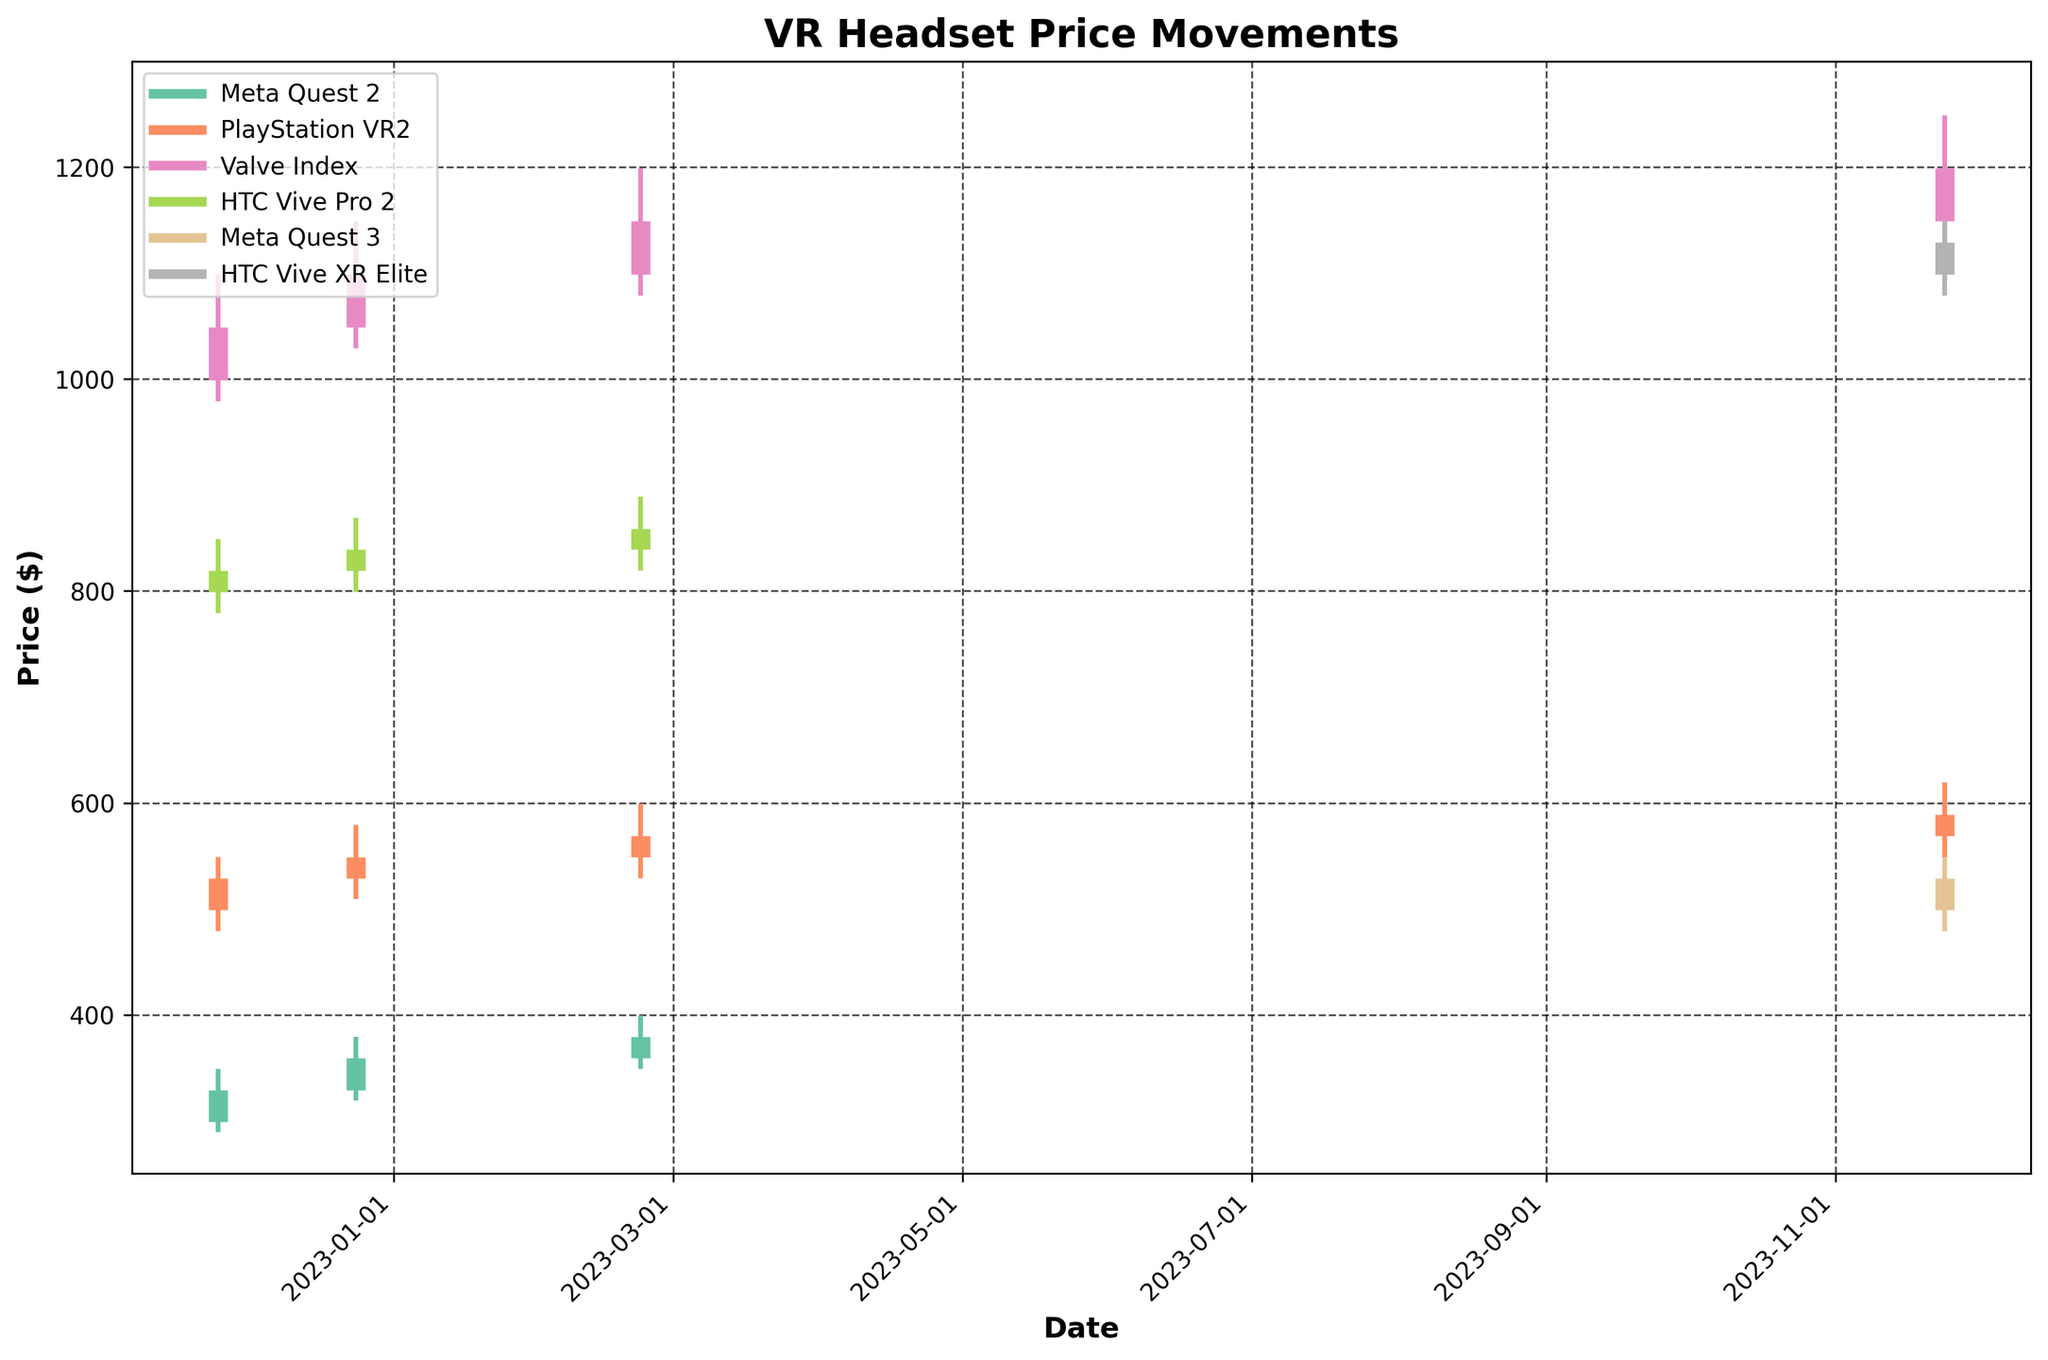How many brands are included in the figure? To determine the number of brands, look for unique labels in the legend.
Answer: 4 What is the highest recorded price for "Meta Quest 3"? For "Meta Quest 3", check the maximum point in the high price line, which shows $549 on 2023-11-24.
Answer: 549 Which VR headset had the highest pre-order price on 2022-11-25? Compare the open prices from 2022-11-25 for all VR headsets and see that "Valve Index" has the highest at $999.
Answer: Valve Index Between which dates did the price of "HTC Vive Pro 2" hit its lowest point? Check the lowest data points for "HTC Vive Pro 2". It hit $779 on 2022-11-25 which is the lowest among all the mentioned dates.
Answer: 2022-11-25 How did the closing price of "PlayStation VR2" change from 2022-12-24 to 2023-02-22? Check the closing prices on both dates (2022-12-24: $549 and 2023-02-22: $569). Subtract the smaller from the larger to determine the change.
Answer: 20 Which VR headset had the smallest range between high and low prices on 2023-11-24? Calculate the range (High - Low) for all headsets on 2023-11-24. The smallest range is "HTC Vive XR Elite" with $1149 - $1079 = $70.
Answer: HTC Vive XR Elite On which date did "Valve Index" have the most significant price increase from open to close? Calculate the increase (Close - Open) on each date for "Valve Index". The greatest increase is on 2022-12-24, increasing $50 ($1099 - $1049).
Answer: 2022-12-24 How does the closing price of "Meta Quest 2" on 2022-11-25 compare to 2022-12-24? Compare the closing prices ($329 on 2022-11-25 and $359 on 2022-12-24). The price increased by $30.
Answer: 30 Which VR headset showed the highest low price on 2023-11-24? Check the low prices for each headset on 2023-11-24 and identify "Valve Index" with $1129 being the highest.
Answer: Valve Index What is the average closing price for "HTC Vive Pro 2" across all dates? Add the closing prices across dates and divide by the number of entries for "HTC Vive Pro 2": (819 + 839 + 859) / 3 = 839.
Answer: 839 